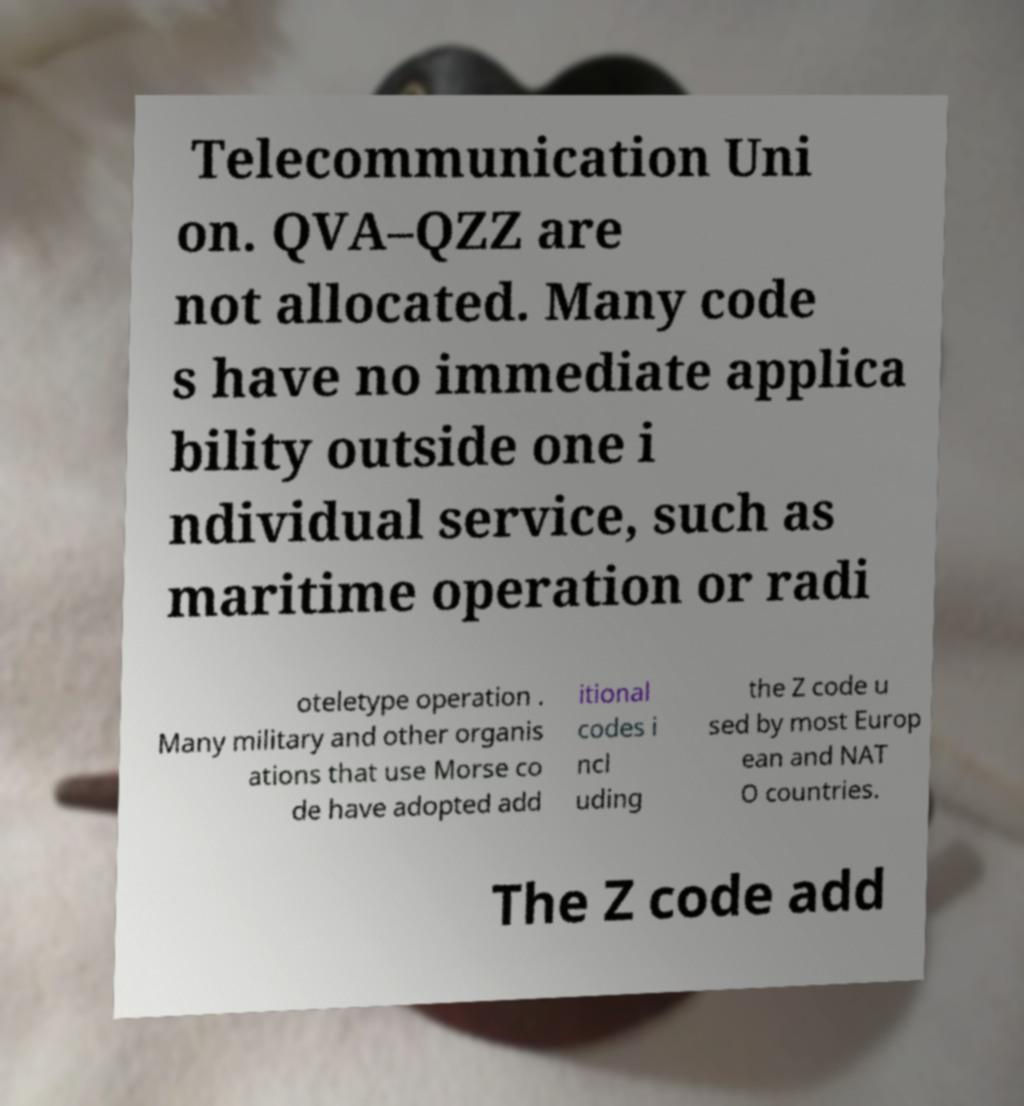What messages or text are displayed in this image? I need them in a readable, typed format. Telecommunication Uni on. QVA–QZZ are not allocated. Many code s have no immediate applica bility outside one i ndividual service, such as maritime operation or radi oteletype operation . Many military and other organis ations that use Morse co de have adopted add itional codes i ncl uding the Z code u sed by most Europ ean and NAT O countries. The Z code add 